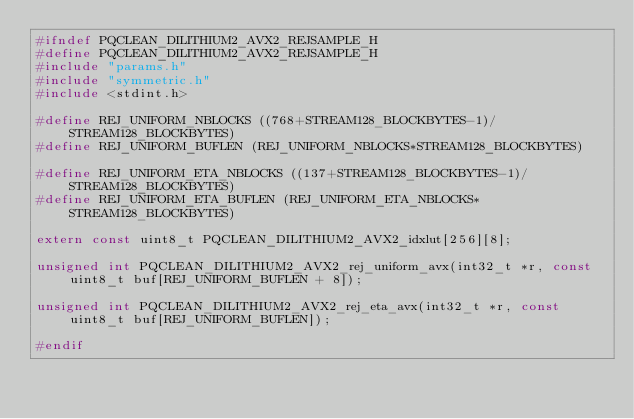Convert code to text. <code><loc_0><loc_0><loc_500><loc_500><_C_>#ifndef PQCLEAN_DILITHIUM2_AVX2_REJSAMPLE_H
#define PQCLEAN_DILITHIUM2_AVX2_REJSAMPLE_H
#include "params.h"
#include "symmetric.h"
#include <stdint.h>

#define REJ_UNIFORM_NBLOCKS ((768+STREAM128_BLOCKBYTES-1)/STREAM128_BLOCKBYTES)
#define REJ_UNIFORM_BUFLEN (REJ_UNIFORM_NBLOCKS*STREAM128_BLOCKBYTES)

#define REJ_UNIFORM_ETA_NBLOCKS ((137+STREAM128_BLOCKBYTES-1)/STREAM128_BLOCKBYTES)
#define REJ_UNIFORM_ETA_BUFLEN (REJ_UNIFORM_ETA_NBLOCKS*STREAM128_BLOCKBYTES)

extern const uint8_t PQCLEAN_DILITHIUM2_AVX2_idxlut[256][8];

unsigned int PQCLEAN_DILITHIUM2_AVX2_rej_uniform_avx(int32_t *r, const uint8_t buf[REJ_UNIFORM_BUFLEN + 8]);

unsigned int PQCLEAN_DILITHIUM2_AVX2_rej_eta_avx(int32_t *r, const uint8_t buf[REJ_UNIFORM_BUFLEN]);

#endif
</code> 